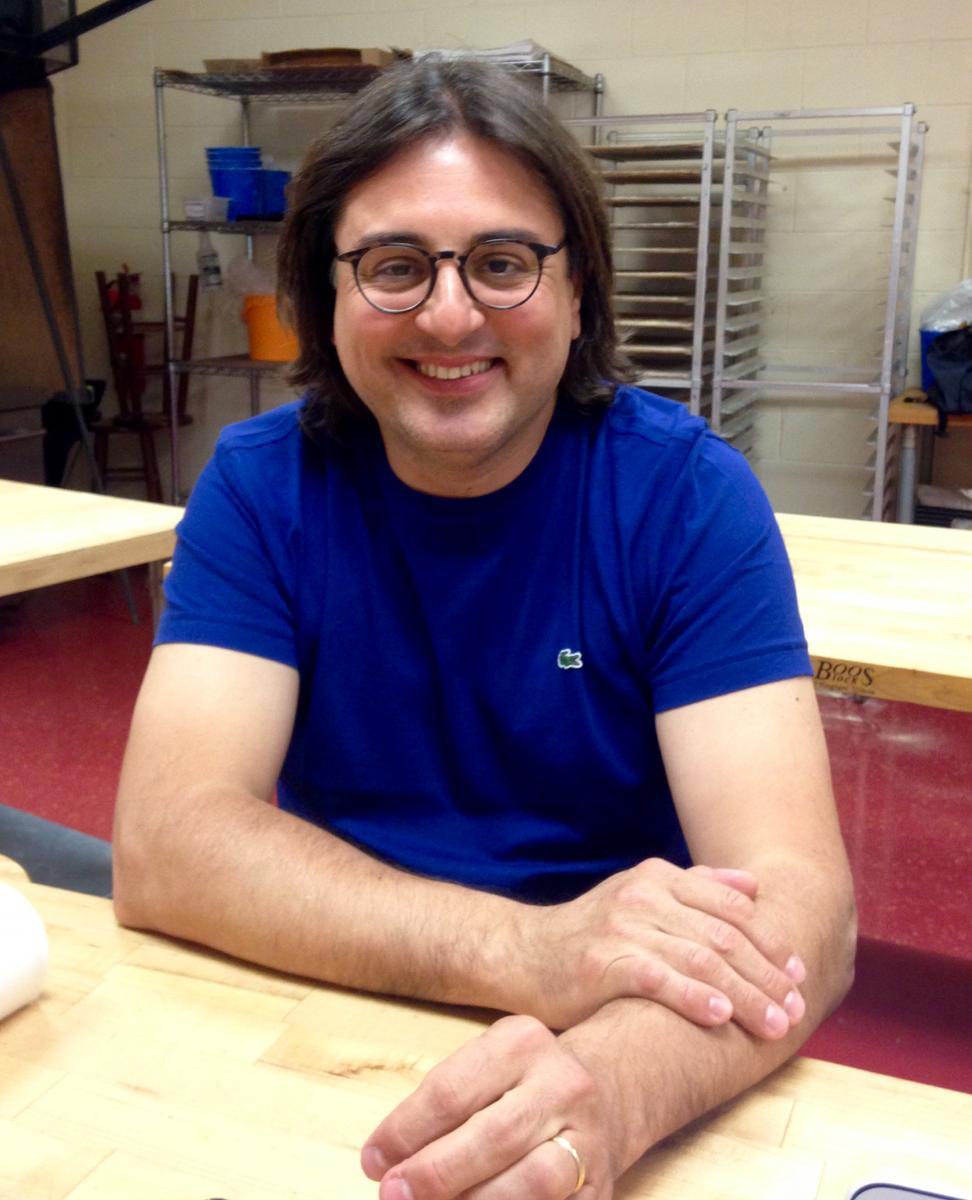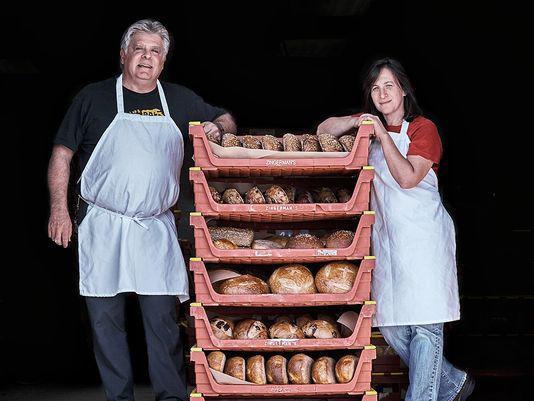The first image is the image on the left, the second image is the image on the right. Evaluate the accuracy of this statement regarding the images: "The rack of bread in one image is flanked by two people in aprons.". Is it true? Answer yes or no. Yes. 